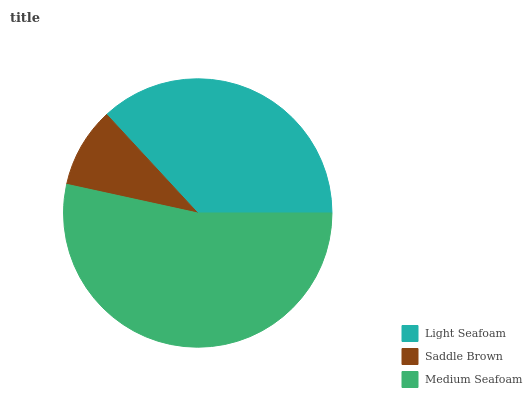Is Saddle Brown the minimum?
Answer yes or no. Yes. Is Medium Seafoam the maximum?
Answer yes or no. Yes. Is Medium Seafoam the minimum?
Answer yes or no. No. Is Saddle Brown the maximum?
Answer yes or no. No. Is Medium Seafoam greater than Saddle Brown?
Answer yes or no. Yes. Is Saddle Brown less than Medium Seafoam?
Answer yes or no. Yes. Is Saddle Brown greater than Medium Seafoam?
Answer yes or no. No. Is Medium Seafoam less than Saddle Brown?
Answer yes or no. No. Is Light Seafoam the high median?
Answer yes or no. Yes. Is Light Seafoam the low median?
Answer yes or no. Yes. Is Saddle Brown the high median?
Answer yes or no. No. Is Medium Seafoam the low median?
Answer yes or no. No. 